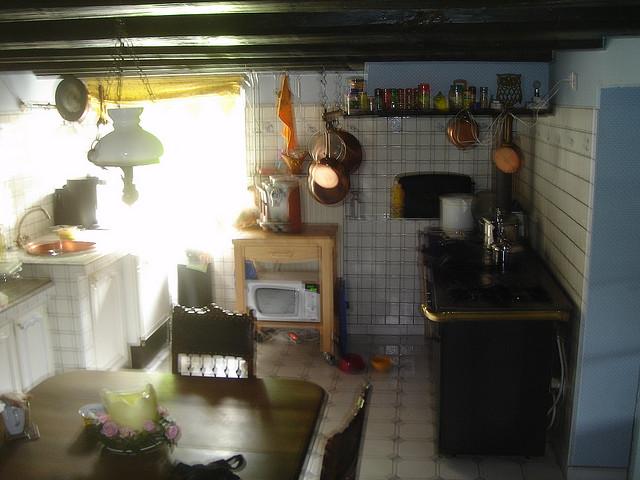Is there a power strip under the microwave?
Keep it brief. Yes. What type of home is this?
Write a very short answer. Small. IS this in black and white?
Short answer required. No. Is this a big kitchen?
Be succinct. No. What time of day is it?
Concise answer only. Morning. What is covering the walls?
Give a very brief answer. Tile. 